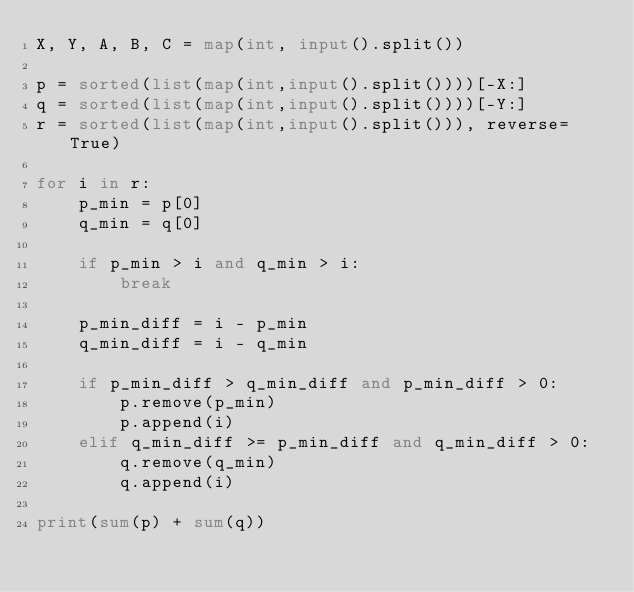Convert code to text. <code><loc_0><loc_0><loc_500><loc_500><_Python_>X, Y, A, B, C = map(int, input().split())

p = sorted(list(map(int,input().split())))[-X:]
q = sorted(list(map(int,input().split())))[-Y:]
r = sorted(list(map(int,input().split())), reverse=True)

for i in r:
    p_min = p[0]
    q_min = q[0]

    if p_min > i and q_min > i:
        break

    p_min_diff = i - p_min
    q_min_diff = i - q_min

    if p_min_diff > q_min_diff and p_min_diff > 0:
        p.remove(p_min)
        p.append(i)
    elif q_min_diff >= p_min_diff and q_min_diff > 0:
        q.remove(q_min)
        q.append(i)

print(sum(p) + sum(q))</code> 